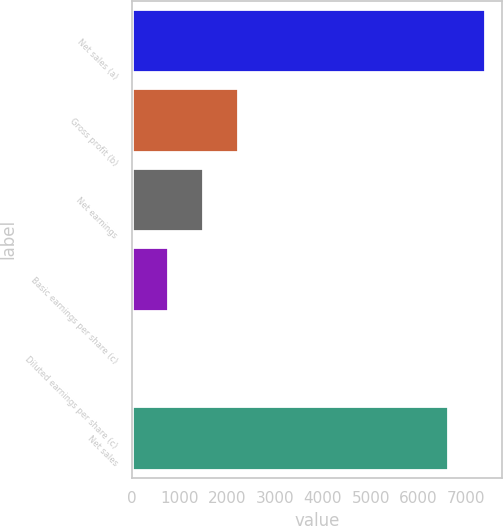<chart> <loc_0><loc_0><loc_500><loc_500><bar_chart><fcel>Net sales (a)<fcel>Gross profit (b)<fcel>Net earnings<fcel>Basic earnings per share (c)<fcel>Diluted earnings per share (c)<fcel>Net sales<nl><fcel>7389.7<fcel>2218.84<fcel>1480.14<fcel>741.44<fcel>2.74<fcel>6621.5<nl></chart> 